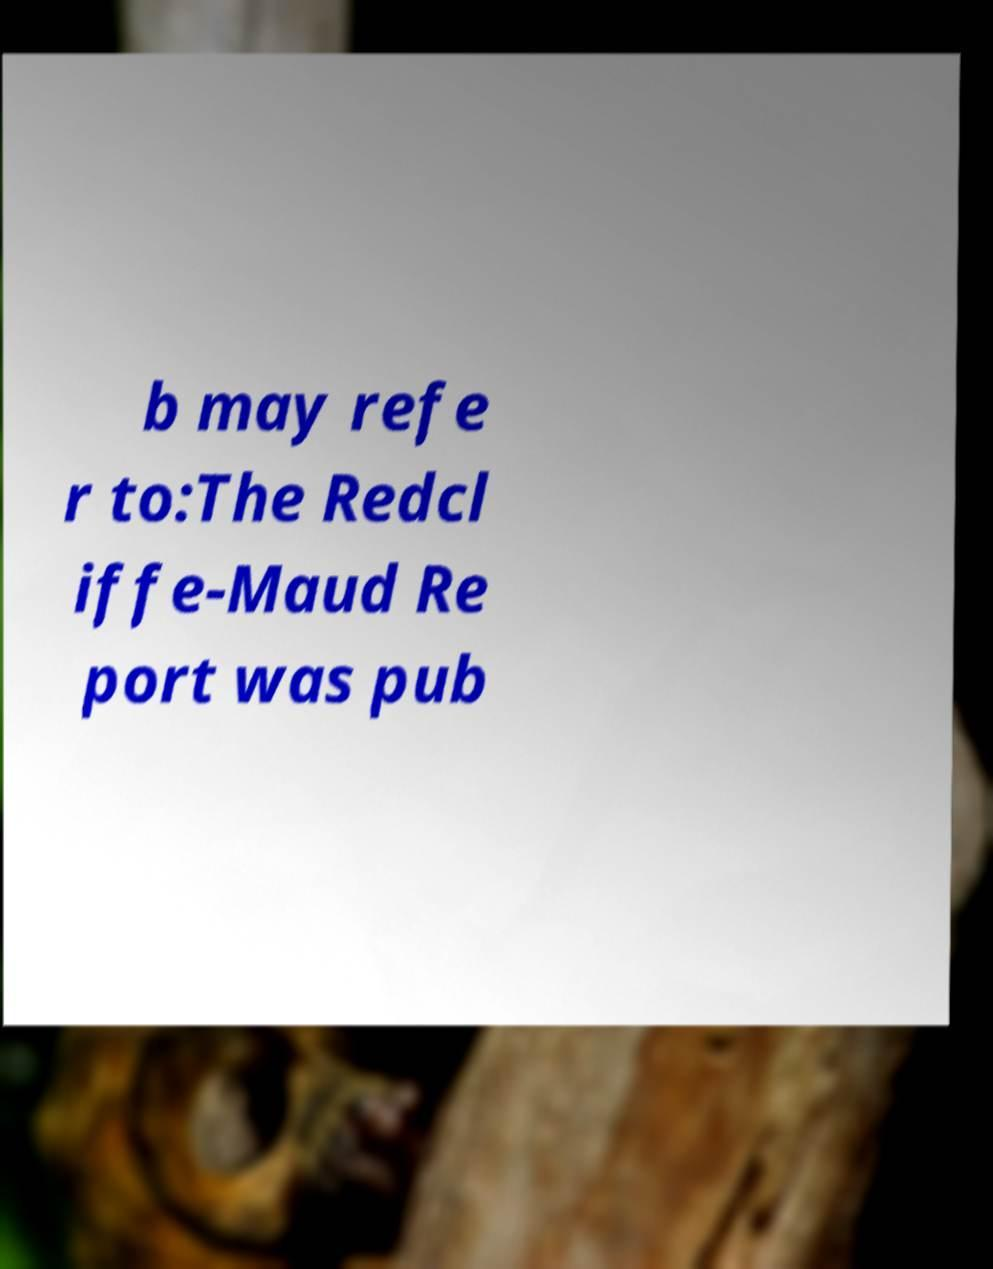I need the written content from this picture converted into text. Can you do that? b may refe r to:The Redcl iffe-Maud Re port was pub 